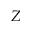Convert formula to latex. <formula><loc_0><loc_0><loc_500><loc_500>Z</formula> 